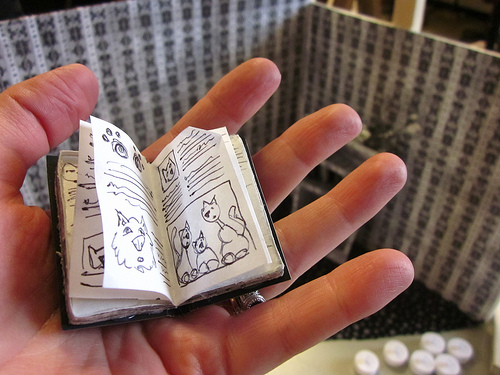<image>
Can you confirm if the man is on the book? No. The man is not positioned on the book. They may be near each other, but the man is not supported by or resting on top of the book. Is the book behind the person? No. The book is not behind the person. From this viewpoint, the book appears to be positioned elsewhere in the scene. 